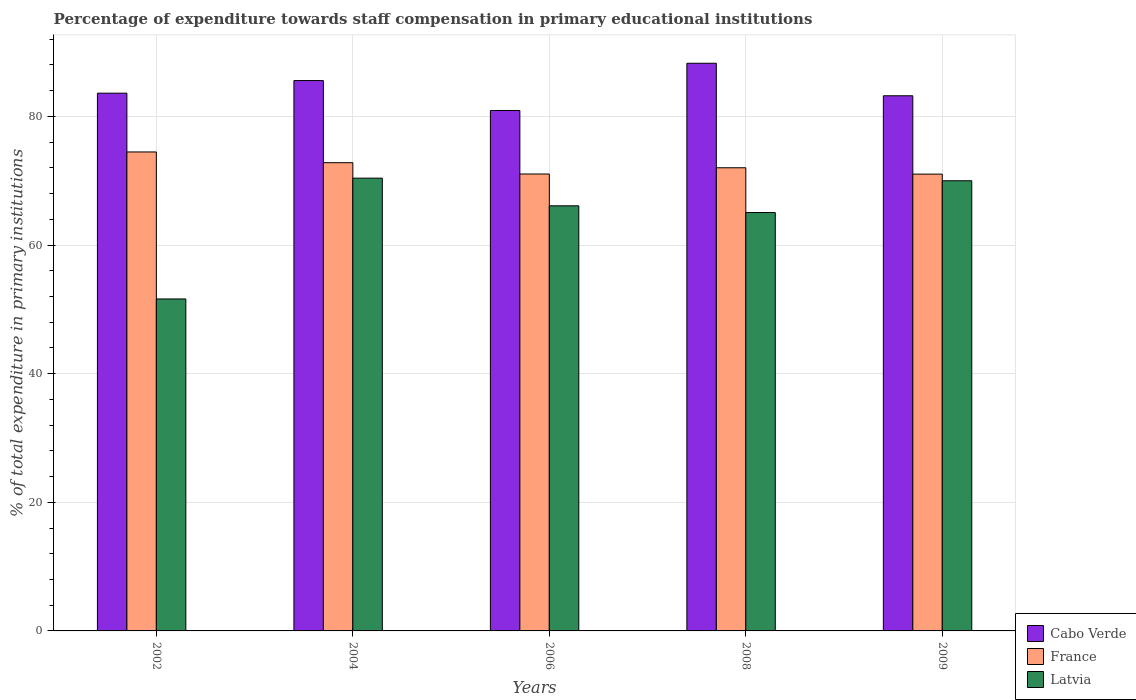How many different coloured bars are there?
Keep it short and to the point. 3. How many groups of bars are there?
Make the answer very short. 5. Are the number of bars on each tick of the X-axis equal?
Provide a short and direct response. Yes. How many bars are there on the 5th tick from the right?
Provide a succinct answer. 3. What is the label of the 2nd group of bars from the left?
Offer a terse response. 2004. In how many cases, is the number of bars for a given year not equal to the number of legend labels?
Ensure brevity in your answer.  0. What is the percentage of expenditure towards staff compensation in France in 2008?
Offer a very short reply. 72.01. Across all years, what is the maximum percentage of expenditure towards staff compensation in Latvia?
Ensure brevity in your answer.  70.39. Across all years, what is the minimum percentage of expenditure towards staff compensation in France?
Your answer should be very brief. 71.02. What is the total percentage of expenditure towards staff compensation in France in the graph?
Provide a short and direct response. 361.34. What is the difference between the percentage of expenditure towards staff compensation in Cabo Verde in 2006 and that in 2008?
Offer a very short reply. -7.34. What is the difference between the percentage of expenditure towards staff compensation in Latvia in 2006 and the percentage of expenditure towards staff compensation in France in 2002?
Your response must be concise. -8.37. What is the average percentage of expenditure towards staff compensation in Cabo Verde per year?
Provide a short and direct response. 84.31. In the year 2006, what is the difference between the percentage of expenditure towards staff compensation in France and percentage of expenditure towards staff compensation in Latvia?
Provide a succinct answer. 4.95. What is the ratio of the percentage of expenditure towards staff compensation in Latvia in 2006 to that in 2009?
Your answer should be very brief. 0.94. Is the percentage of expenditure towards staff compensation in Cabo Verde in 2002 less than that in 2004?
Provide a succinct answer. Yes. Is the difference between the percentage of expenditure towards staff compensation in France in 2002 and 2006 greater than the difference between the percentage of expenditure towards staff compensation in Latvia in 2002 and 2006?
Ensure brevity in your answer.  Yes. What is the difference between the highest and the second highest percentage of expenditure towards staff compensation in Cabo Verde?
Provide a succinct answer. 2.69. What is the difference between the highest and the lowest percentage of expenditure towards staff compensation in France?
Make the answer very short. 3.44. In how many years, is the percentage of expenditure towards staff compensation in Cabo Verde greater than the average percentage of expenditure towards staff compensation in Cabo Verde taken over all years?
Provide a succinct answer. 2. Is the sum of the percentage of expenditure towards staff compensation in France in 2002 and 2008 greater than the maximum percentage of expenditure towards staff compensation in Cabo Verde across all years?
Provide a short and direct response. Yes. What does the 2nd bar from the left in 2008 represents?
Your answer should be compact. France. Are all the bars in the graph horizontal?
Your response must be concise. No. How many years are there in the graph?
Your answer should be compact. 5. What is the difference between two consecutive major ticks on the Y-axis?
Offer a terse response. 20. Does the graph contain any zero values?
Provide a succinct answer. No. How are the legend labels stacked?
Give a very brief answer. Vertical. What is the title of the graph?
Provide a short and direct response. Percentage of expenditure towards staff compensation in primary educational institutions. What is the label or title of the Y-axis?
Give a very brief answer. % of total expenditure in primary institutions. What is the % of total expenditure in primary institutions in Cabo Verde in 2002?
Offer a terse response. 83.6. What is the % of total expenditure in primary institutions in France in 2002?
Your response must be concise. 74.47. What is the % of total expenditure in primary institutions in Latvia in 2002?
Keep it short and to the point. 51.61. What is the % of total expenditure in primary institutions in Cabo Verde in 2004?
Make the answer very short. 85.57. What is the % of total expenditure in primary institutions of France in 2004?
Ensure brevity in your answer.  72.8. What is the % of total expenditure in primary institutions of Latvia in 2004?
Offer a very short reply. 70.39. What is the % of total expenditure in primary institutions in Cabo Verde in 2006?
Give a very brief answer. 80.91. What is the % of total expenditure in primary institutions of France in 2006?
Your answer should be compact. 71.04. What is the % of total expenditure in primary institutions of Latvia in 2006?
Provide a succinct answer. 66.09. What is the % of total expenditure in primary institutions in Cabo Verde in 2008?
Offer a very short reply. 88.26. What is the % of total expenditure in primary institutions of France in 2008?
Make the answer very short. 72.01. What is the % of total expenditure in primary institutions in Latvia in 2008?
Your answer should be very brief. 65.05. What is the % of total expenditure in primary institutions of Cabo Verde in 2009?
Offer a terse response. 83.2. What is the % of total expenditure in primary institutions of France in 2009?
Give a very brief answer. 71.02. What is the % of total expenditure in primary institutions of Latvia in 2009?
Ensure brevity in your answer.  69.99. Across all years, what is the maximum % of total expenditure in primary institutions of Cabo Verde?
Offer a terse response. 88.26. Across all years, what is the maximum % of total expenditure in primary institutions of France?
Offer a terse response. 74.47. Across all years, what is the maximum % of total expenditure in primary institutions in Latvia?
Provide a succinct answer. 70.39. Across all years, what is the minimum % of total expenditure in primary institutions in Cabo Verde?
Offer a terse response. 80.91. Across all years, what is the minimum % of total expenditure in primary institutions in France?
Offer a very short reply. 71.02. Across all years, what is the minimum % of total expenditure in primary institutions of Latvia?
Your answer should be compact. 51.61. What is the total % of total expenditure in primary institutions in Cabo Verde in the graph?
Ensure brevity in your answer.  421.54. What is the total % of total expenditure in primary institutions in France in the graph?
Give a very brief answer. 361.34. What is the total % of total expenditure in primary institutions in Latvia in the graph?
Ensure brevity in your answer.  323.14. What is the difference between the % of total expenditure in primary institutions of Cabo Verde in 2002 and that in 2004?
Make the answer very short. -1.96. What is the difference between the % of total expenditure in primary institutions of France in 2002 and that in 2004?
Offer a terse response. 1.67. What is the difference between the % of total expenditure in primary institutions of Latvia in 2002 and that in 2004?
Keep it short and to the point. -18.78. What is the difference between the % of total expenditure in primary institutions of Cabo Verde in 2002 and that in 2006?
Your response must be concise. 2.69. What is the difference between the % of total expenditure in primary institutions of France in 2002 and that in 2006?
Offer a terse response. 3.43. What is the difference between the % of total expenditure in primary institutions in Latvia in 2002 and that in 2006?
Provide a succinct answer. -14.48. What is the difference between the % of total expenditure in primary institutions of Cabo Verde in 2002 and that in 2008?
Offer a terse response. -4.65. What is the difference between the % of total expenditure in primary institutions of France in 2002 and that in 2008?
Ensure brevity in your answer.  2.46. What is the difference between the % of total expenditure in primary institutions of Latvia in 2002 and that in 2008?
Keep it short and to the point. -13.43. What is the difference between the % of total expenditure in primary institutions of Cabo Verde in 2002 and that in 2009?
Provide a short and direct response. 0.4. What is the difference between the % of total expenditure in primary institutions of France in 2002 and that in 2009?
Provide a succinct answer. 3.44. What is the difference between the % of total expenditure in primary institutions of Latvia in 2002 and that in 2009?
Offer a very short reply. -18.38. What is the difference between the % of total expenditure in primary institutions in Cabo Verde in 2004 and that in 2006?
Offer a terse response. 4.65. What is the difference between the % of total expenditure in primary institutions in France in 2004 and that in 2006?
Provide a succinct answer. 1.76. What is the difference between the % of total expenditure in primary institutions in Latvia in 2004 and that in 2006?
Ensure brevity in your answer.  4.3. What is the difference between the % of total expenditure in primary institutions of Cabo Verde in 2004 and that in 2008?
Your answer should be very brief. -2.69. What is the difference between the % of total expenditure in primary institutions in France in 2004 and that in 2008?
Your response must be concise. 0.79. What is the difference between the % of total expenditure in primary institutions in Latvia in 2004 and that in 2008?
Provide a short and direct response. 5.35. What is the difference between the % of total expenditure in primary institutions in Cabo Verde in 2004 and that in 2009?
Give a very brief answer. 2.37. What is the difference between the % of total expenditure in primary institutions in France in 2004 and that in 2009?
Make the answer very short. 1.78. What is the difference between the % of total expenditure in primary institutions of Latvia in 2004 and that in 2009?
Offer a very short reply. 0.41. What is the difference between the % of total expenditure in primary institutions in Cabo Verde in 2006 and that in 2008?
Keep it short and to the point. -7.34. What is the difference between the % of total expenditure in primary institutions in France in 2006 and that in 2008?
Offer a terse response. -0.97. What is the difference between the % of total expenditure in primary institutions of Latvia in 2006 and that in 2008?
Keep it short and to the point. 1.05. What is the difference between the % of total expenditure in primary institutions in Cabo Verde in 2006 and that in 2009?
Give a very brief answer. -2.29. What is the difference between the % of total expenditure in primary institutions of France in 2006 and that in 2009?
Make the answer very short. 0.02. What is the difference between the % of total expenditure in primary institutions in Latvia in 2006 and that in 2009?
Your answer should be compact. -3.9. What is the difference between the % of total expenditure in primary institutions of Cabo Verde in 2008 and that in 2009?
Provide a short and direct response. 5.06. What is the difference between the % of total expenditure in primary institutions in France in 2008 and that in 2009?
Your response must be concise. 0.99. What is the difference between the % of total expenditure in primary institutions in Latvia in 2008 and that in 2009?
Provide a short and direct response. -4.94. What is the difference between the % of total expenditure in primary institutions of Cabo Verde in 2002 and the % of total expenditure in primary institutions of France in 2004?
Ensure brevity in your answer.  10.8. What is the difference between the % of total expenditure in primary institutions in Cabo Verde in 2002 and the % of total expenditure in primary institutions in Latvia in 2004?
Keep it short and to the point. 13.21. What is the difference between the % of total expenditure in primary institutions in France in 2002 and the % of total expenditure in primary institutions in Latvia in 2004?
Keep it short and to the point. 4.07. What is the difference between the % of total expenditure in primary institutions of Cabo Verde in 2002 and the % of total expenditure in primary institutions of France in 2006?
Make the answer very short. 12.57. What is the difference between the % of total expenditure in primary institutions of Cabo Verde in 2002 and the % of total expenditure in primary institutions of Latvia in 2006?
Your response must be concise. 17.51. What is the difference between the % of total expenditure in primary institutions of France in 2002 and the % of total expenditure in primary institutions of Latvia in 2006?
Keep it short and to the point. 8.37. What is the difference between the % of total expenditure in primary institutions of Cabo Verde in 2002 and the % of total expenditure in primary institutions of France in 2008?
Give a very brief answer. 11.6. What is the difference between the % of total expenditure in primary institutions of Cabo Verde in 2002 and the % of total expenditure in primary institutions of Latvia in 2008?
Give a very brief answer. 18.56. What is the difference between the % of total expenditure in primary institutions of France in 2002 and the % of total expenditure in primary institutions of Latvia in 2008?
Your answer should be very brief. 9.42. What is the difference between the % of total expenditure in primary institutions in Cabo Verde in 2002 and the % of total expenditure in primary institutions in France in 2009?
Your response must be concise. 12.58. What is the difference between the % of total expenditure in primary institutions in Cabo Verde in 2002 and the % of total expenditure in primary institutions in Latvia in 2009?
Make the answer very short. 13.62. What is the difference between the % of total expenditure in primary institutions in France in 2002 and the % of total expenditure in primary institutions in Latvia in 2009?
Ensure brevity in your answer.  4.48. What is the difference between the % of total expenditure in primary institutions of Cabo Verde in 2004 and the % of total expenditure in primary institutions of France in 2006?
Give a very brief answer. 14.53. What is the difference between the % of total expenditure in primary institutions in Cabo Verde in 2004 and the % of total expenditure in primary institutions in Latvia in 2006?
Your response must be concise. 19.47. What is the difference between the % of total expenditure in primary institutions of France in 2004 and the % of total expenditure in primary institutions of Latvia in 2006?
Keep it short and to the point. 6.71. What is the difference between the % of total expenditure in primary institutions in Cabo Verde in 2004 and the % of total expenditure in primary institutions in France in 2008?
Your answer should be very brief. 13.56. What is the difference between the % of total expenditure in primary institutions of Cabo Verde in 2004 and the % of total expenditure in primary institutions of Latvia in 2008?
Ensure brevity in your answer.  20.52. What is the difference between the % of total expenditure in primary institutions in France in 2004 and the % of total expenditure in primary institutions in Latvia in 2008?
Your answer should be very brief. 7.75. What is the difference between the % of total expenditure in primary institutions of Cabo Verde in 2004 and the % of total expenditure in primary institutions of France in 2009?
Ensure brevity in your answer.  14.55. What is the difference between the % of total expenditure in primary institutions in Cabo Verde in 2004 and the % of total expenditure in primary institutions in Latvia in 2009?
Offer a very short reply. 15.58. What is the difference between the % of total expenditure in primary institutions of France in 2004 and the % of total expenditure in primary institutions of Latvia in 2009?
Your answer should be very brief. 2.81. What is the difference between the % of total expenditure in primary institutions of Cabo Verde in 2006 and the % of total expenditure in primary institutions of France in 2008?
Make the answer very short. 8.9. What is the difference between the % of total expenditure in primary institutions of Cabo Verde in 2006 and the % of total expenditure in primary institutions of Latvia in 2008?
Provide a succinct answer. 15.87. What is the difference between the % of total expenditure in primary institutions of France in 2006 and the % of total expenditure in primary institutions of Latvia in 2008?
Provide a succinct answer. 5.99. What is the difference between the % of total expenditure in primary institutions in Cabo Verde in 2006 and the % of total expenditure in primary institutions in France in 2009?
Provide a succinct answer. 9.89. What is the difference between the % of total expenditure in primary institutions of Cabo Verde in 2006 and the % of total expenditure in primary institutions of Latvia in 2009?
Ensure brevity in your answer.  10.92. What is the difference between the % of total expenditure in primary institutions in France in 2006 and the % of total expenditure in primary institutions in Latvia in 2009?
Give a very brief answer. 1.05. What is the difference between the % of total expenditure in primary institutions in Cabo Verde in 2008 and the % of total expenditure in primary institutions in France in 2009?
Keep it short and to the point. 17.23. What is the difference between the % of total expenditure in primary institutions in Cabo Verde in 2008 and the % of total expenditure in primary institutions in Latvia in 2009?
Ensure brevity in your answer.  18.27. What is the difference between the % of total expenditure in primary institutions in France in 2008 and the % of total expenditure in primary institutions in Latvia in 2009?
Make the answer very short. 2.02. What is the average % of total expenditure in primary institutions of Cabo Verde per year?
Ensure brevity in your answer.  84.31. What is the average % of total expenditure in primary institutions of France per year?
Provide a succinct answer. 72.27. What is the average % of total expenditure in primary institutions in Latvia per year?
Ensure brevity in your answer.  64.63. In the year 2002, what is the difference between the % of total expenditure in primary institutions in Cabo Verde and % of total expenditure in primary institutions in France?
Provide a succinct answer. 9.14. In the year 2002, what is the difference between the % of total expenditure in primary institutions in Cabo Verde and % of total expenditure in primary institutions in Latvia?
Your response must be concise. 31.99. In the year 2002, what is the difference between the % of total expenditure in primary institutions in France and % of total expenditure in primary institutions in Latvia?
Ensure brevity in your answer.  22.85. In the year 2004, what is the difference between the % of total expenditure in primary institutions of Cabo Verde and % of total expenditure in primary institutions of France?
Offer a terse response. 12.77. In the year 2004, what is the difference between the % of total expenditure in primary institutions of Cabo Verde and % of total expenditure in primary institutions of Latvia?
Offer a terse response. 15.17. In the year 2004, what is the difference between the % of total expenditure in primary institutions in France and % of total expenditure in primary institutions in Latvia?
Offer a terse response. 2.41. In the year 2006, what is the difference between the % of total expenditure in primary institutions of Cabo Verde and % of total expenditure in primary institutions of France?
Your response must be concise. 9.87. In the year 2006, what is the difference between the % of total expenditure in primary institutions of Cabo Verde and % of total expenditure in primary institutions of Latvia?
Provide a succinct answer. 14.82. In the year 2006, what is the difference between the % of total expenditure in primary institutions in France and % of total expenditure in primary institutions in Latvia?
Provide a short and direct response. 4.95. In the year 2008, what is the difference between the % of total expenditure in primary institutions of Cabo Verde and % of total expenditure in primary institutions of France?
Offer a terse response. 16.25. In the year 2008, what is the difference between the % of total expenditure in primary institutions in Cabo Verde and % of total expenditure in primary institutions in Latvia?
Give a very brief answer. 23.21. In the year 2008, what is the difference between the % of total expenditure in primary institutions in France and % of total expenditure in primary institutions in Latvia?
Give a very brief answer. 6.96. In the year 2009, what is the difference between the % of total expenditure in primary institutions of Cabo Verde and % of total expenditure in primary institutions of France?
Ensure brevity in your answer.  12.18. In the year 2009, what is the difference between the % of total expenditure in primary institutions in Cabo Verde and % of total expenditure in primary institutions in Latvia?
Your answer should be very brief. 13.21. In the year 2009, what is the difference between the % of total expenditure in primary institutions of France and % of total expenditure in primary institutions of Latvia?
Your answer should be very brief. 1.03. What is the ratio of the % of total expenditure in primary institutions in Cabo Verde in 2002 to that in 2004?
Your answer should be very brief. 0.98. What is the ratio of the % of total expenditure in primary institutions in France in 2002 to that in 2004?
Make the answer very short. 1.02. What is the ratio of the % of total expenditure in primary institutions in Latvia in 2002 to that in 2004?
Provide a short and direct response. 0.73. What is the ratio of the % of total expenditure in primary institutions of Cabo Verde in 2002 to that in 2006?
Provide a succinct answer. 1.03. What is the ratio of the % of total expenditure in primary institutions of France in 2002 to that in 2006?
Give a very brief answer. 1.05. What is the ratio of the % of total expenditure in primary institutions of Latvia in 2002 to that in 2006?
Offer a terse response. 0.78. What is the ratio of the % of total expenditure in primary institutions in Cabo Verde in 2002 to that in 2008?
Offer a very short reply. 0.95. What is the ratio of the % of total expenditure in primary institutions of France in 2002 to that in 2008?
Give a very brief answer. 1.03. What is the ratio of the % of total expenditure in primary institutions of Latvia in 2002 to that in 2008?
Your answer should be very brief. 0.79. What is the ratio of the % of total expenditure in primary institutions of Cabo Verde in 2002 to that in 2009?
Offer a terse response. 1. What is the ratio of the % of total expenditure in primary institutions in France in 2002 to that in 2009?
Keep it short and to the point. 1.05. What is the ratio of the % of total expenditure in primary institutions in Latvia in 2002 to that in 2009?
Make the answer very short. 0.74. What is the ratio of the % of total expenditure in primary institutions of Cabo Verde in 2004 to that in 2006?
Keep it short and to the point. 1.06. What is the ratio of the % of total expenditure in primary institutions of France in 2004 to that in 2006?
Your answer should be compact. 1.02. What is the ratio of the % of total expenditure in primary institutions in Latvia in 2004 to that in 2006?
Your response must be concise. 1.07. What is the ratio of the % of total expenditure in primary institutions of Cabo Verde in 2004 to that in 2008?
Offer a very short reply. 0.97. What is the ratio of the % of total expenditure in primary institutions in Latvia in 2004 to that in 2008?
Keep it short and to the point. 1.08. What is the ratio of the % of total expenditure in primary institutions of Cabo Verde in 2004 to that in 2009?
Offer a terse response. 1.03. What is the ratio of the % of total expenditure in primary institutions of Latvia in 2004 to that in 2009?
Offer a very short reply. 1.01. What is the ratio of the % of total expenditure in primary institutions of Cabo Verde in 2006 to that in 2008?
Offer a very short reply. 0.92. What is the ratio of the % of total expenditure in primary institutions of France in 2006 to that in 2008?
Offer a terse response. 0.99. What is the ratio of the % of total expenditure in primary institutions of Latvia in 2006 to that in 2008?
Ensure brevity in your answer.  1.02. What is the ratio of the % of total expenditure in primary institutions in Cabo Verde in 2006 to that in 2009?
Offer a terse response. 0.97. What is the ratio of the % of total expenditure in primary institutions of Latvia in 2006 to that in 2009?
Make the answer very short. 0.94. What is the ratio of the % of total expenditure in primary institutions in Cabo Verde in 2008 to that in 2009?
Make the answer very short. 1.06. What is the ratio of the % of total expenditure in primary institutions in France in 2008 to that in 2009?
Offer a terse response. 1.01. What is the ratio of the % of total expenditure in primary institutions in Latvia in 2008 to that in 2009?
Your response must be concise. 0.93. What is the difference between the highest and the second highest % of total expenditure in primary institutions of Cabo Verde?
Offer a terse response. 2.69. What is the difference between the highest and the second highest % of total expenditure in primary institutions in France?
Offer a very short reply. 1.67. What is the difference between the highest and the second highest % of total expenditure in primary institutions of Latvia?
Your answer should be compact. 0.41. What is the difference between the highest and the lowest % of total expenditure in primary institutions in Cabo Verde?
Your response must be concise. 7.34. What is the difference between the highest and the lowest % of total expenditure in primary institutions in France?
Offer a terse response. 3.44. What is the difference between the highest and the lowest % of total expenditure in primary institutions of Latvia?
Give a very brief answer. 18.78. 